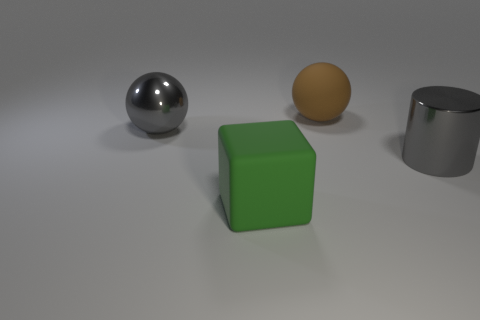What is the material of the big thing that is the same color as the metal cylinder?
Keep it short and to the point. Metal. What size is the sphere that is the same color as the shiny cylinder?
Provide a short and direct response. Large. Are there any other things that are the same color as the cylinder?
Keep it short and to the point. Yes. How many metallic objects are on the left side of the gray cylinder and to the right of the big green object?
Offer a very short reply. 0. There is a object that is the same material as the brown ball; what is its size?
Your response must be concise. Large. What material is the gray ball?
Provide a succinct answer. Metal. Is the size of the rubber thing behind the gray ball the same as the large green thing?
Your answer should be very brief. Yes. What number of objects are brown matte objects or big blue cylinders?
Your answer should be compact. 1. What is the shape of the object that is the same color as the metal ball?
Keep it short and to the point. Cylinder. How many large yellow metallic cylinders are there?
Offer a terse response. 0. 